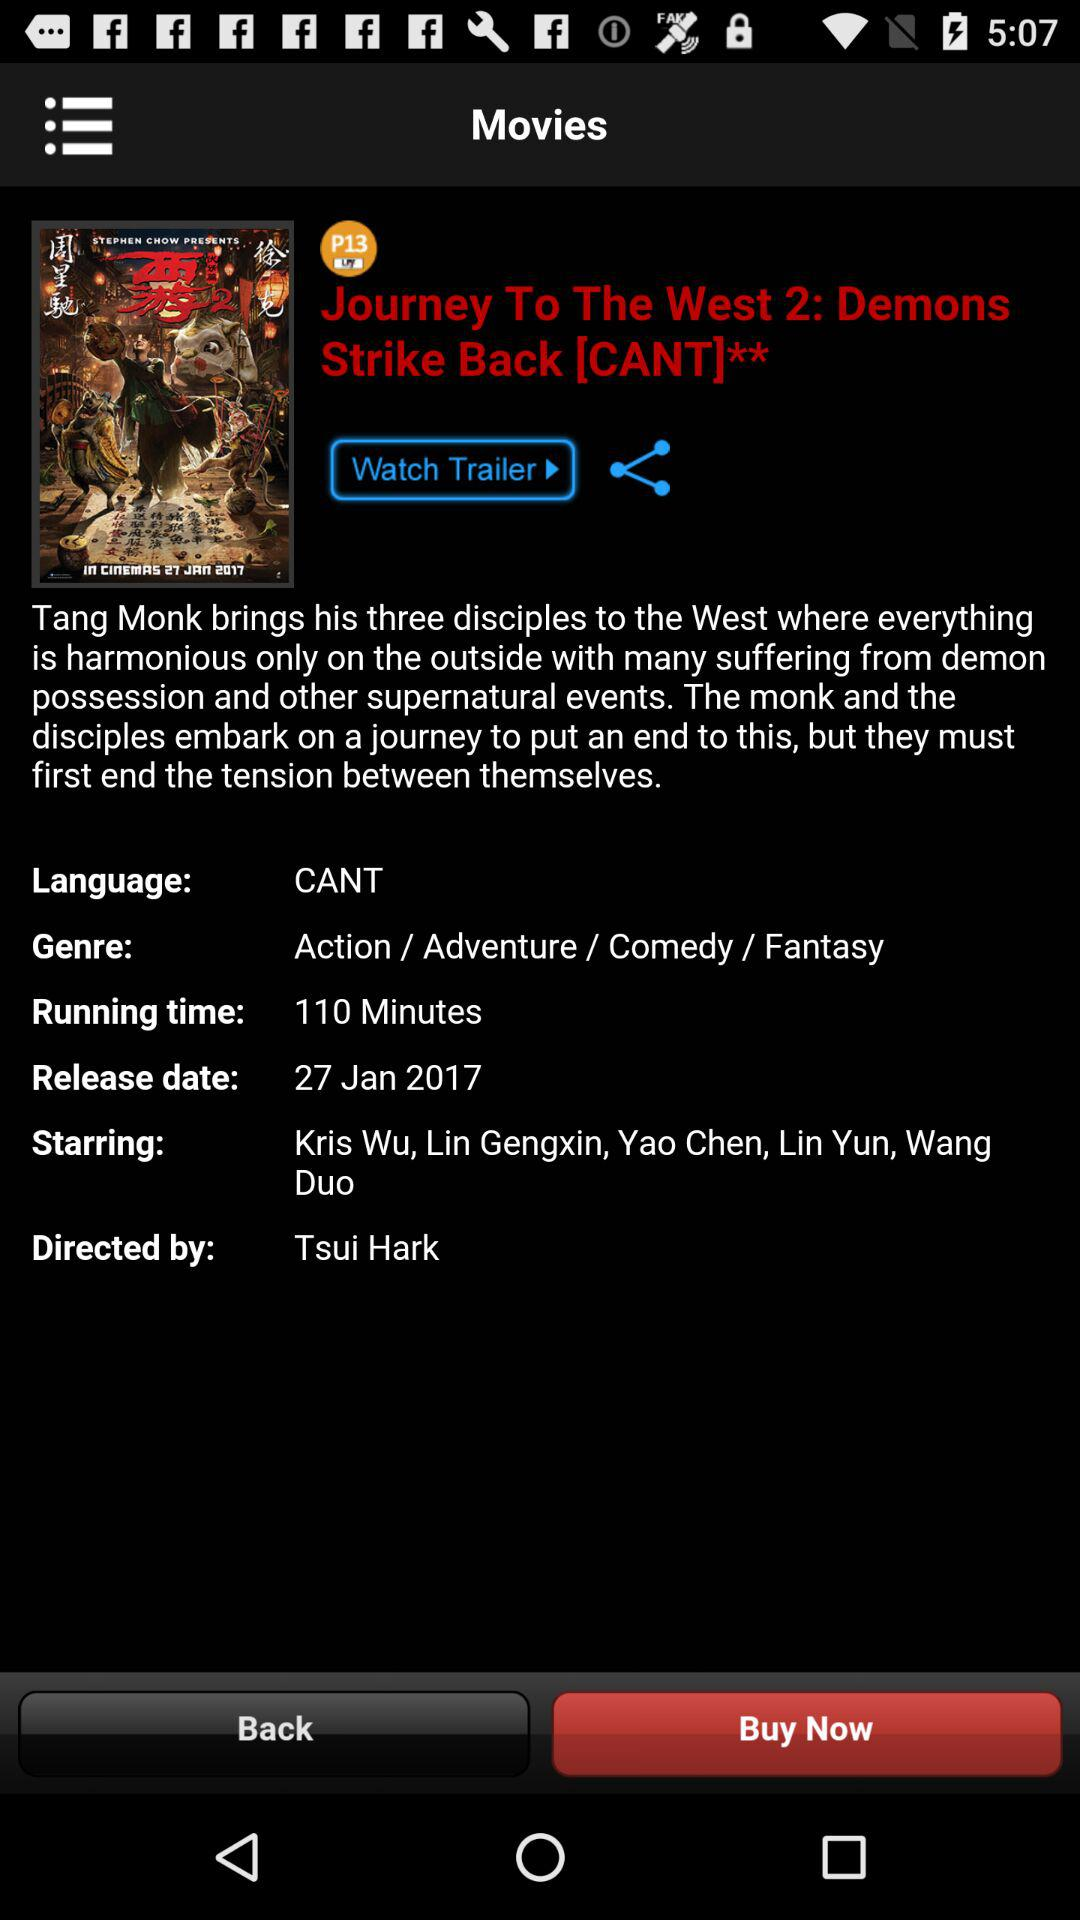What's the release date of the movie? The release date of the movie is January 27, 2017. 